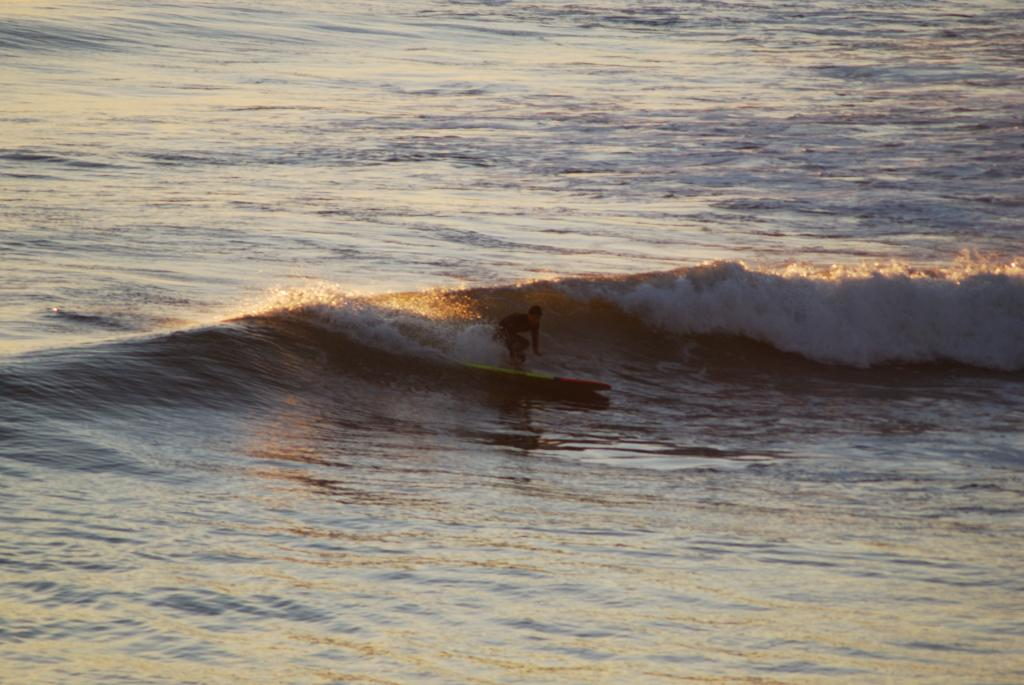What is the main setting of the image? The image depicts a sea. What activity is the person in the image engaged in? The person is surfing in the image. What tool is the person using to surf? The person is using a surfboard. Where is the surfboard located in relation to the water? The surfboard is on the water. What type of spoon is being used to caption the image? There is no spoon or caption present in the image. Is the person in the image currently serving a prison sentence? There is no information about the person's legal status in the image, so it cannot be determined from the image alone. 